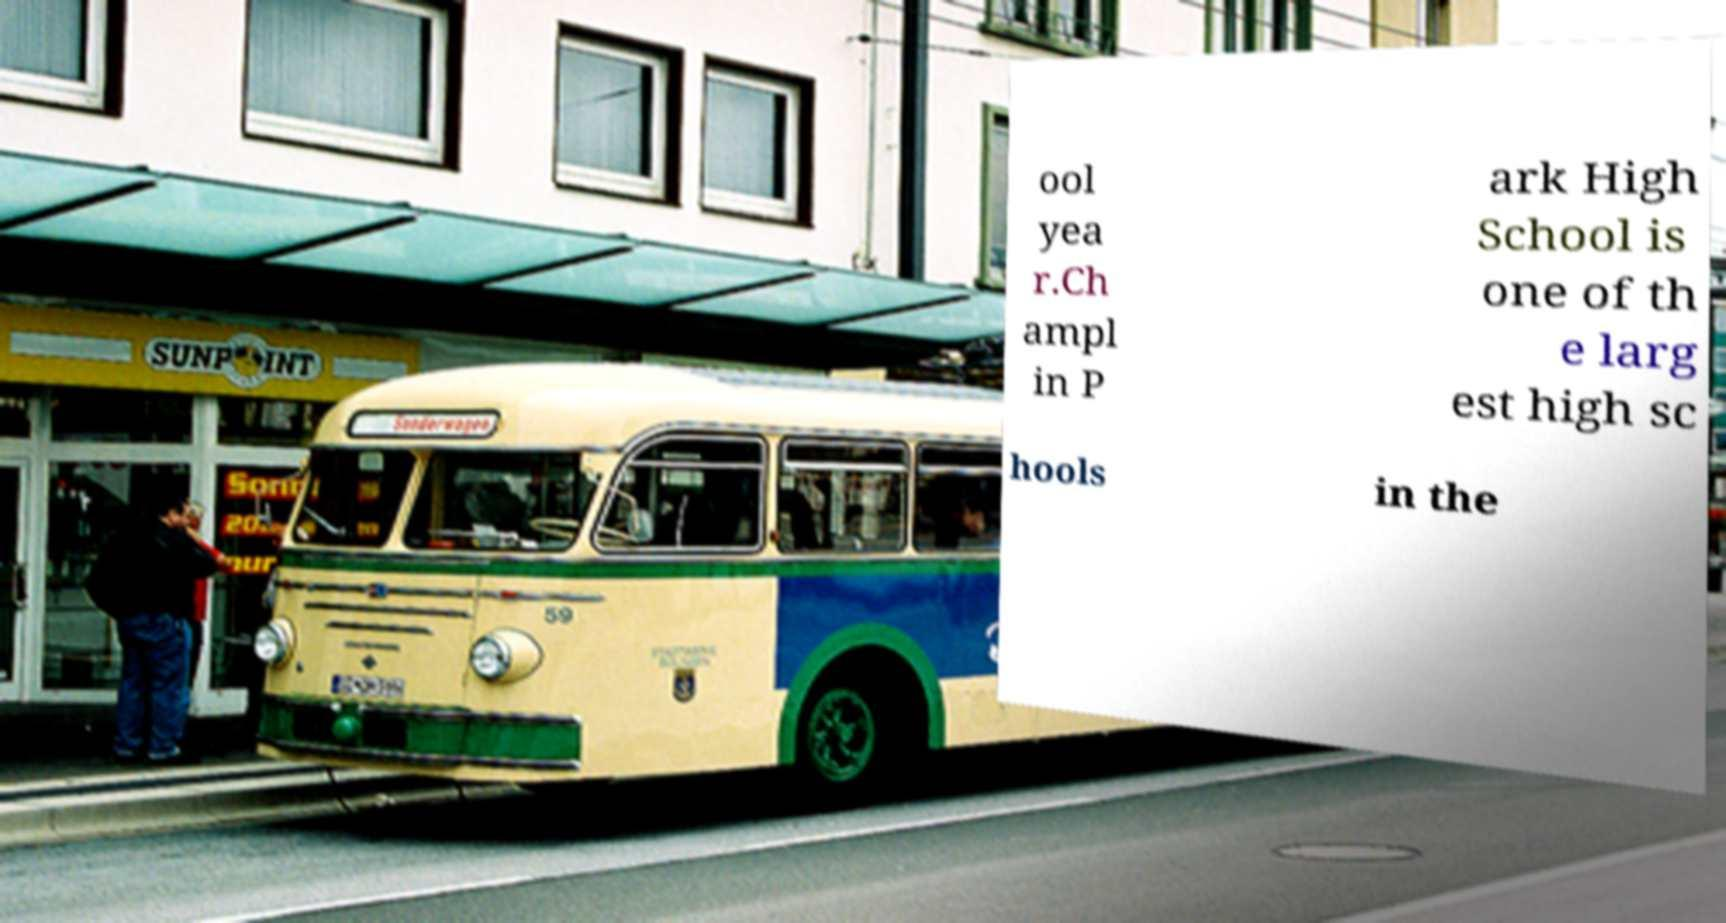There's text embedded in this image that I need extracted. Can you transcribe it verbatim? ool yea r.Ch ampl in P ark High School is one of th e larg est high sc hools in the 